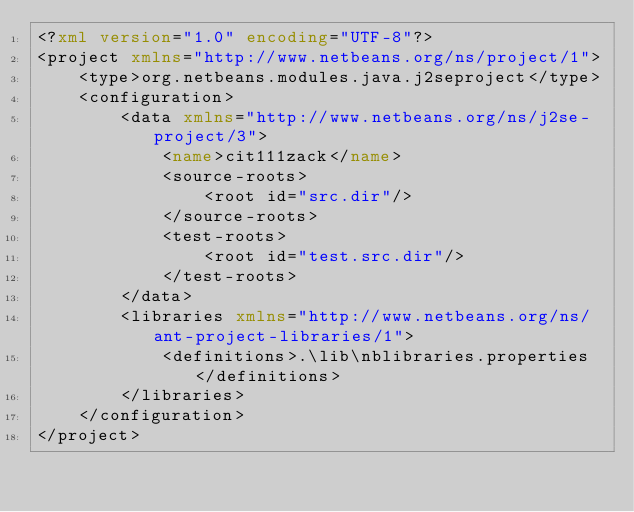Convert code to text. <code><loc_0><loc_0><loc_500><loc_500><_XML_><?xml version="1.0" encoding="UTF-8"?>
<project xmlns="http://www.netbeans.org/ns/project/1">
    <type>org.netbeans.modules.java.j2seproject</type>
    <configuration>
        <data xmlns="http://www.netbeans.org/ns/j2se-project/3">
            <name>cit111zack</name>
            <source-roots>
                <root id="src.dir"/>
            </source-roots>
            <test-roots>
                <root id="test.src.dir"/>
            </test-roots>
        </data>
        <libraries xmlns="http://www.netbeans.org/ns/ant-project-libraries/1">
            <definitions>.\lib\nblibraries.properties</definitions>
        </libraries>
    </configuration>
</project>
</code> 